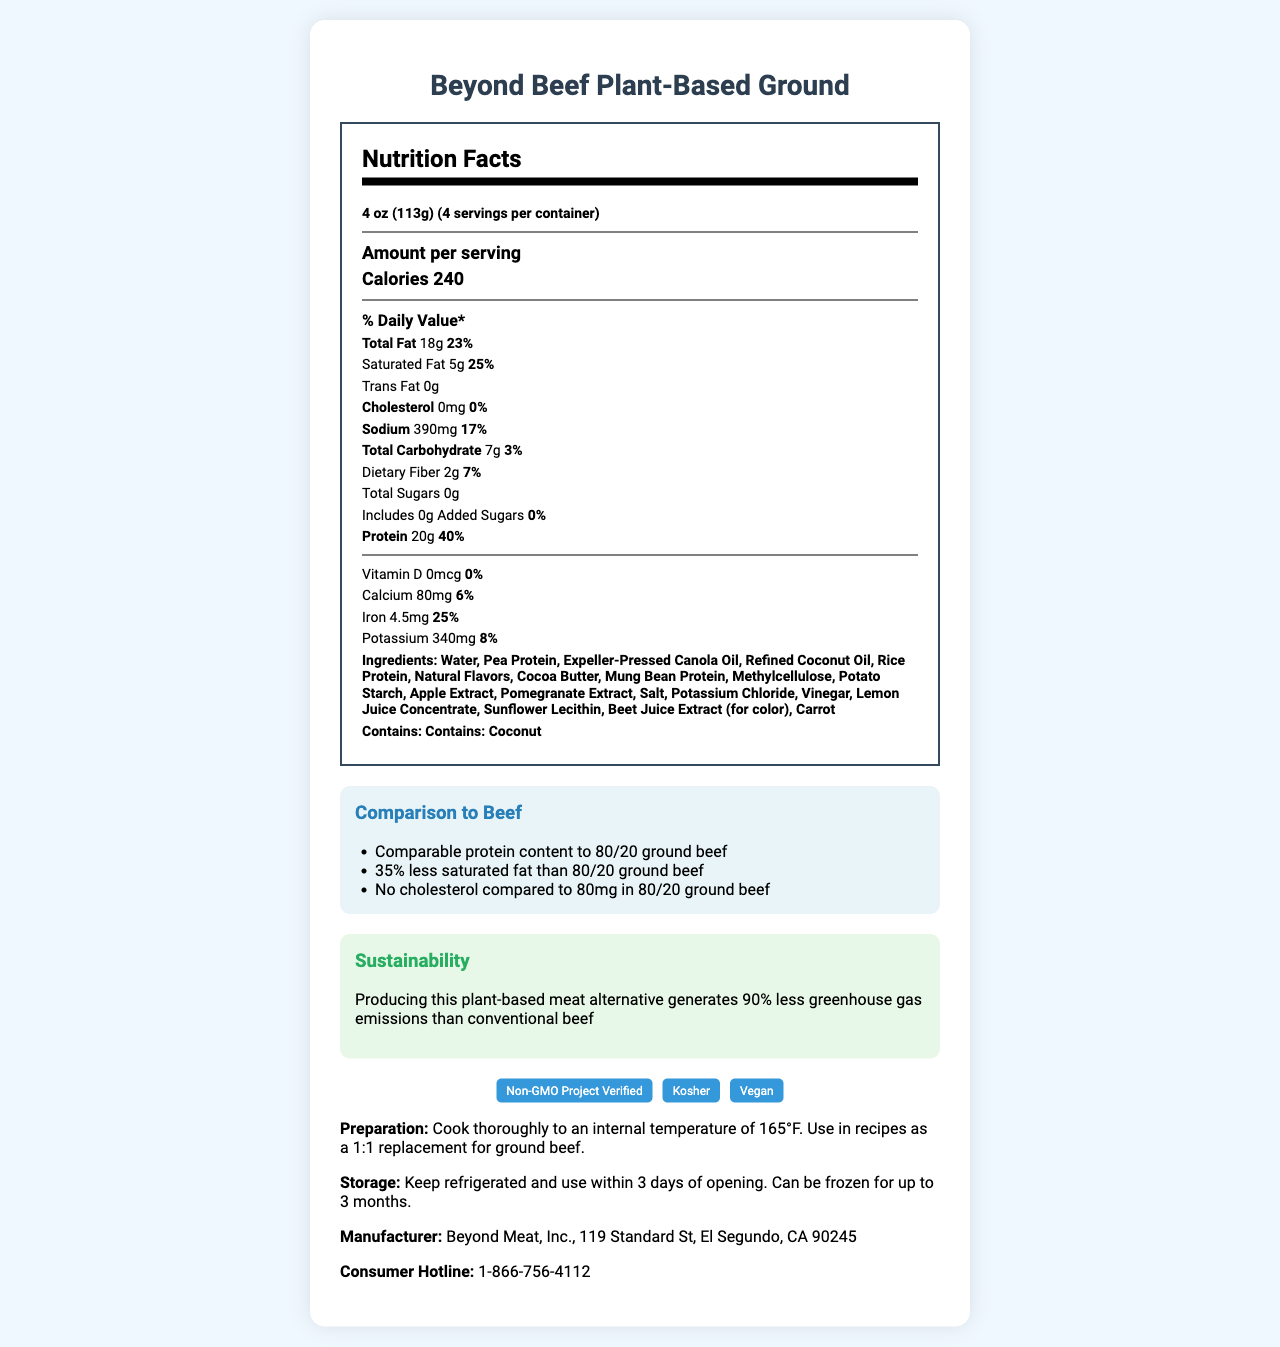what is the serving size of the product? The serving size is explicitly stated near the top of the Nutrition Facts section.
Answer: 4 oz (113g) how many servings are there per container? The document mentions "servings per container: 4" directly.
Answer: 4 how many grams of protein are in one serving? Under the Nutrition Facts, it lists "Protein: 20g."
Answer: 20g what percentage of the daily value of calcium does one serving provide? The document specifies this percentage under the calcium amount in the Nutrition Facts section.
Answer: 6% how much sodium is in one serving? The amount of sodium per serving is shown as 390mg in the Nutrition Facts.
Answer: 390mg which ingredient is highlighted as an allergen? The allergen information states "Contains: Coconut."
Answer: Coconut how does the protein content of this product compare to traditional 80/20 ground beef? Under the comparison to beef section, it's mentioned that the product has comparable protein content to 80/20 ground beef.
Answer: Comparable protein content which certification ensures that the product is not derived from genetically modified organisms? A. Kosher B. Non-GMO Project Verified C. Vegan The certification "Non-GMO Project Verified" ensures the product is not derived from genetically modified organisms.
Answer: B. Non-GMO Project Verified what is the main ingredient in this plant-based meat alternative? A. Pea Protein B. Rice Protein C. Mung Bean Protein D. Potato Starch The ingredient list starts with "Water, Pea Protein," indicating it's the main ingredient.
Answer: A. Pea Protein how many grams of dietary fiber does one serving contain? A. 1g B. 2g C. 3g D. 5g The Nutrition Facts section specifies that each serving contains 2g of dietary fiber.
Answer: B. 2g does the product contain any added sugars? The document states "Includes 0g Added Sugars."
Answer: No is there any cholesterol in this product? The Nutrition Facts section shows "Cholesterol: 0mg" and "Percent Daily Value: 0%."
Answer: No summarize the main idea of this document. The document gives a comprehensive overview of the product's nutritional facts, ingredients, and additional useful consumer information. It highlights how the plant-based product compares to traditional beef, particularly noting its protein content, lower saturated fat, and absence of cholesterol. Furthermore, it emphasizes sustainability benefits and includes certifications like Non-GMO, Kosher, and Vegan.
Answer: The document provides detailed nutritional information about Beyond Beef Plant-Based Ground, including its comparison to traditional beef, allergen information, ingredient list, sustainability benefits, preparation tips, storage instructions, certifications, and manufacturer's contact information. what is the exact flavoring agent used in the Beyond Beef Plant-Based Ground? The document lists "Natural Flavors" as an ingredient, but does not specify what these natural flavors are exactly.
Answer: Cannot be determined 